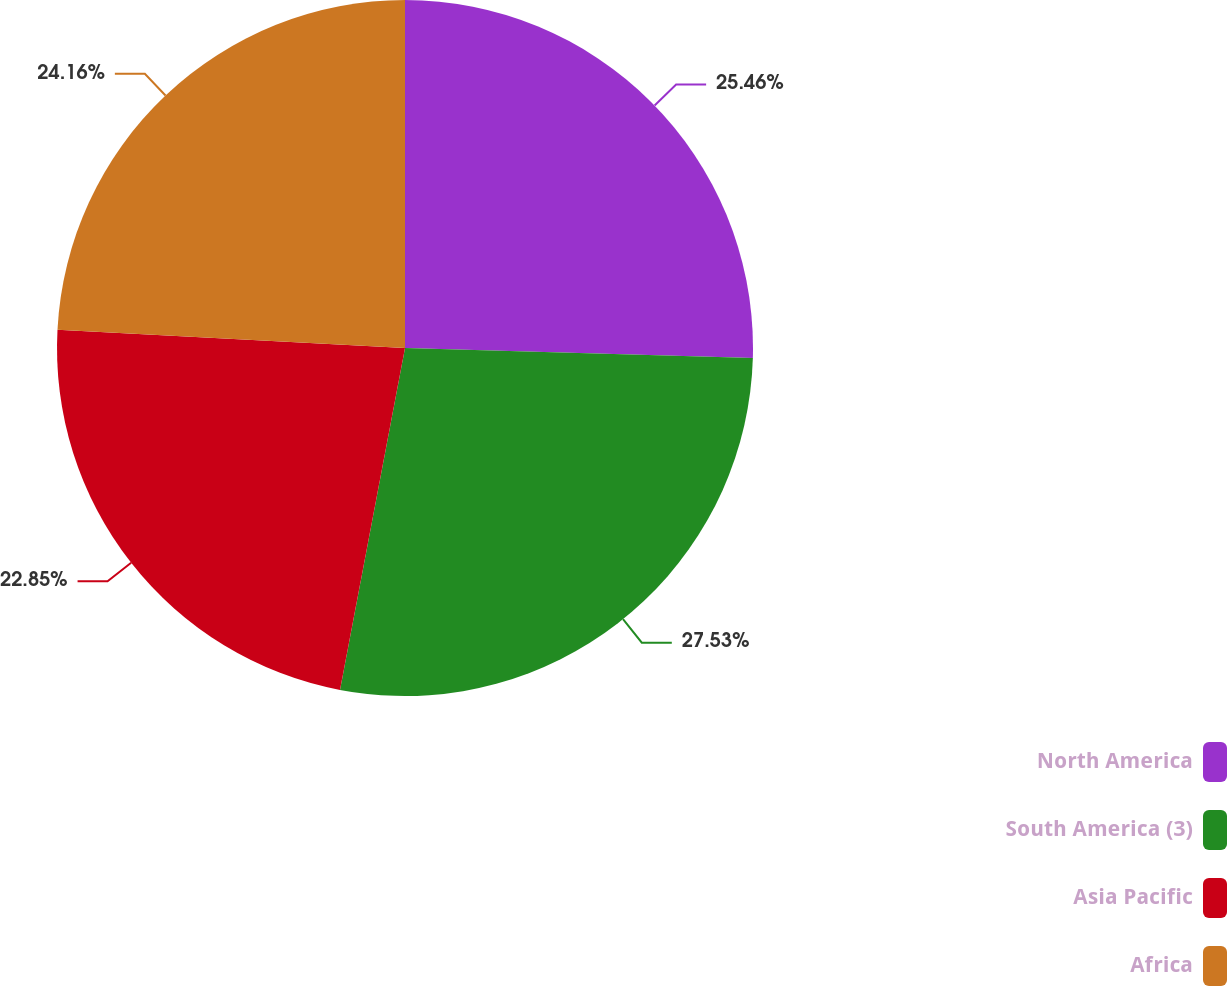<chart> <loc_0><loc_0><loc_500><loc_500><pie_chart><fcel>North America<fcel>South America (3)<fcel>Asia Pacific<fcel>Africa<nl><fcel>25.46%<fcel>27.53%<fcel>22.85%<fcel>24.16%<nl></chart> 